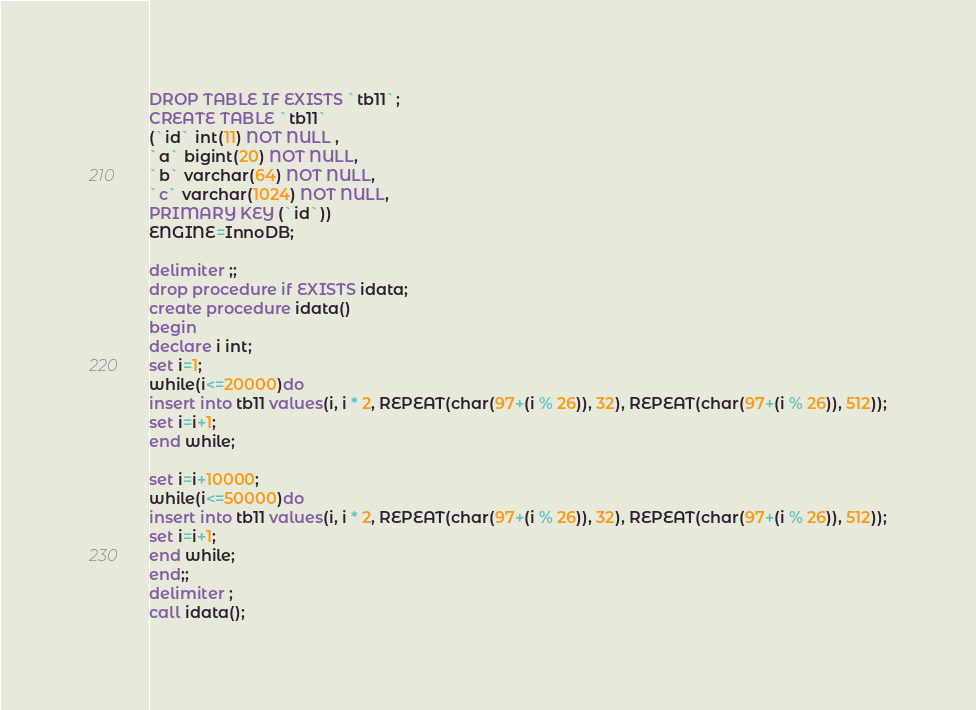Convert code to text. <code><loc_0><loc_0><loc_500><loc_500><_SQL_>DROP TABLE IF EXISTS `tb11`;
CREATE TABLE `tb11`
(`id` int(11) NOT NULL ,
`a` bigint(20) NOT NULL,
`b` varchar(64) NOT NULL,
`c` varchar(1024) NOT NULL,
PRIMARY KEY (`id`))
ENGINE=InnoDB;

delimiter ;;
drop procedure if EXISTS idata;
create procedure idata()
begin
declare i int;
set i=1;
while(i<=20000)do
insert into tb11 values(i, i * 2, REPEAT(char(97+(i % 26)), 32), REPEAT(char(97+(i % 26)), 512));
set i=i+1;
end while;

set i=i+10000;
while(i<=50000)do
insert into tb11 values(i, i * 2, REPEAT(char(97+(i % 26)), 32), REPEAT(char(97+(i % 26)), 512));
set i=i+1;
end while;
end;;
delimiter ;
call idata();</code> 